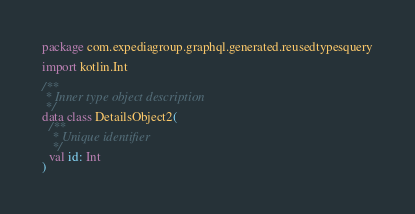<code> <loc_0><loc_0><loc_500><loc_500><_Kotlin_>package com.expediagroup.graphql.generated.reusedtypesquery

import kotlin.Int

/**
 * Inner type object description
 */
data class DetailsObject2(
  /**
   * Unique identifier
   */
  val id: Int
)
</code> 